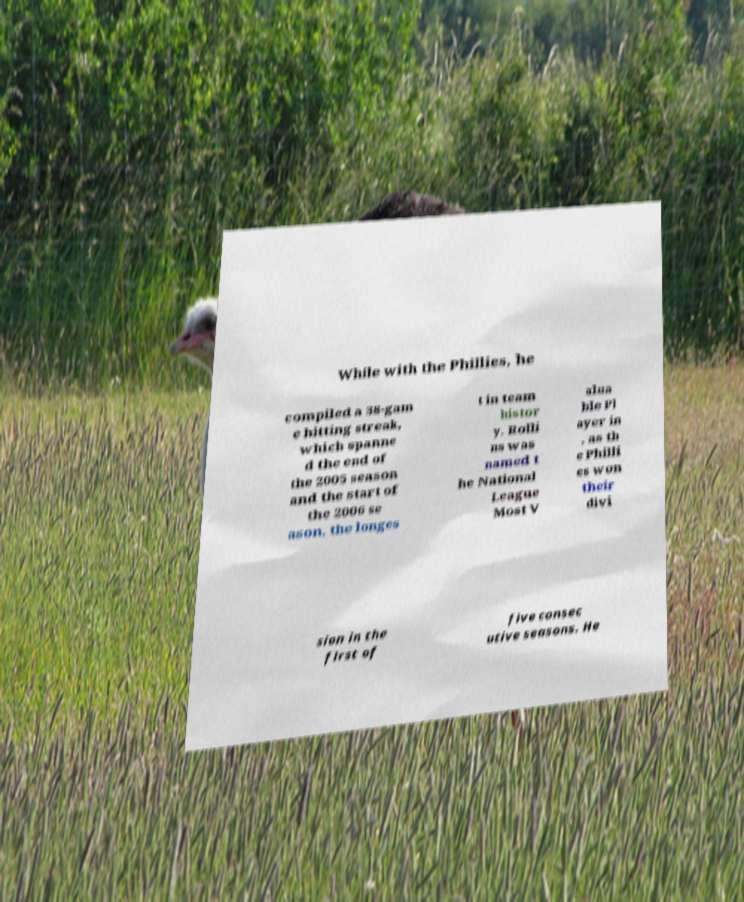What messages or text are displayed in this image? I need them in a readable, typed format. While with the Phillies, he compiled a 38-gam e hitting streak, which spanne d the end of the 2005 season and the start of the 2006 se ason, the longes t in team histor y. Rolli ns was named t he National League Most V alua ble Pl ayer in , as th e Philli es won their divi sion in the first of five consec utive seasons. He 